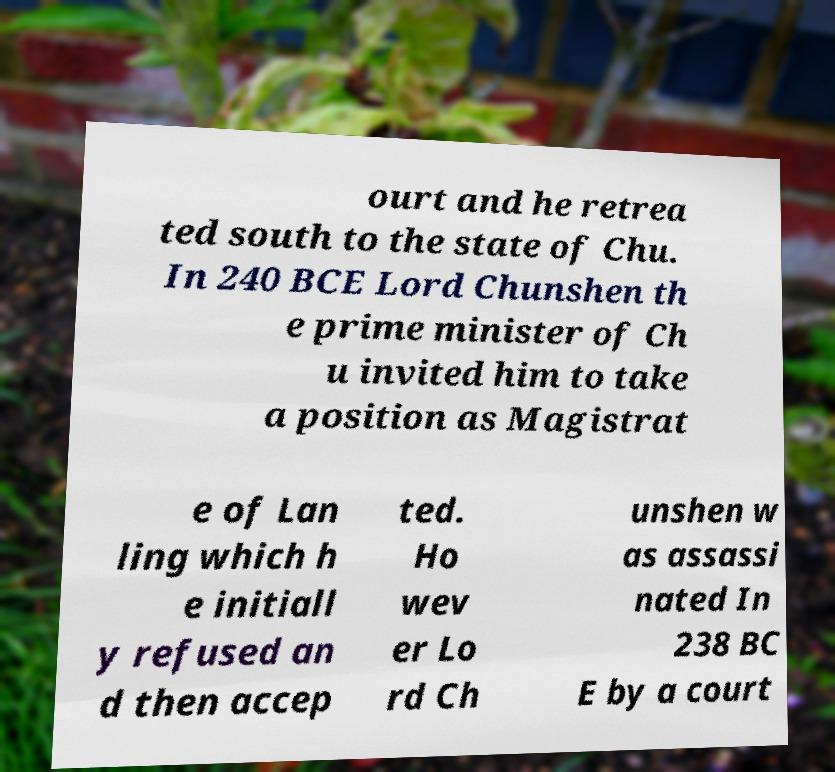Please identify and transcribe the text found in this image. ourt and he retrea ted south to the state of Chu. In 240 BCE Lord Chunshen th e prime minister of Ch u invited him to take a position as Magistrat e of Lan ling which h e initiall y refused an d then accep ted. Ho wev er Lo rd Ch unshen w as assassi nated In 238 BC E by a court 